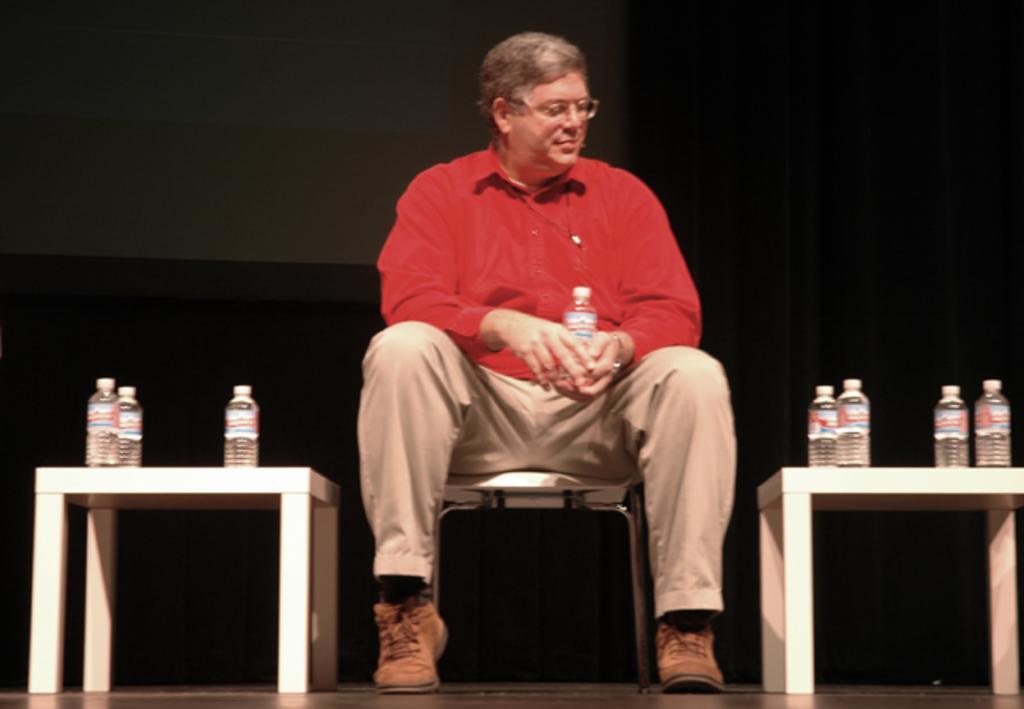Please provide a concise description of this image. As we can see in the image there are tables and a man sitting on chair. On tables there are bottles. 